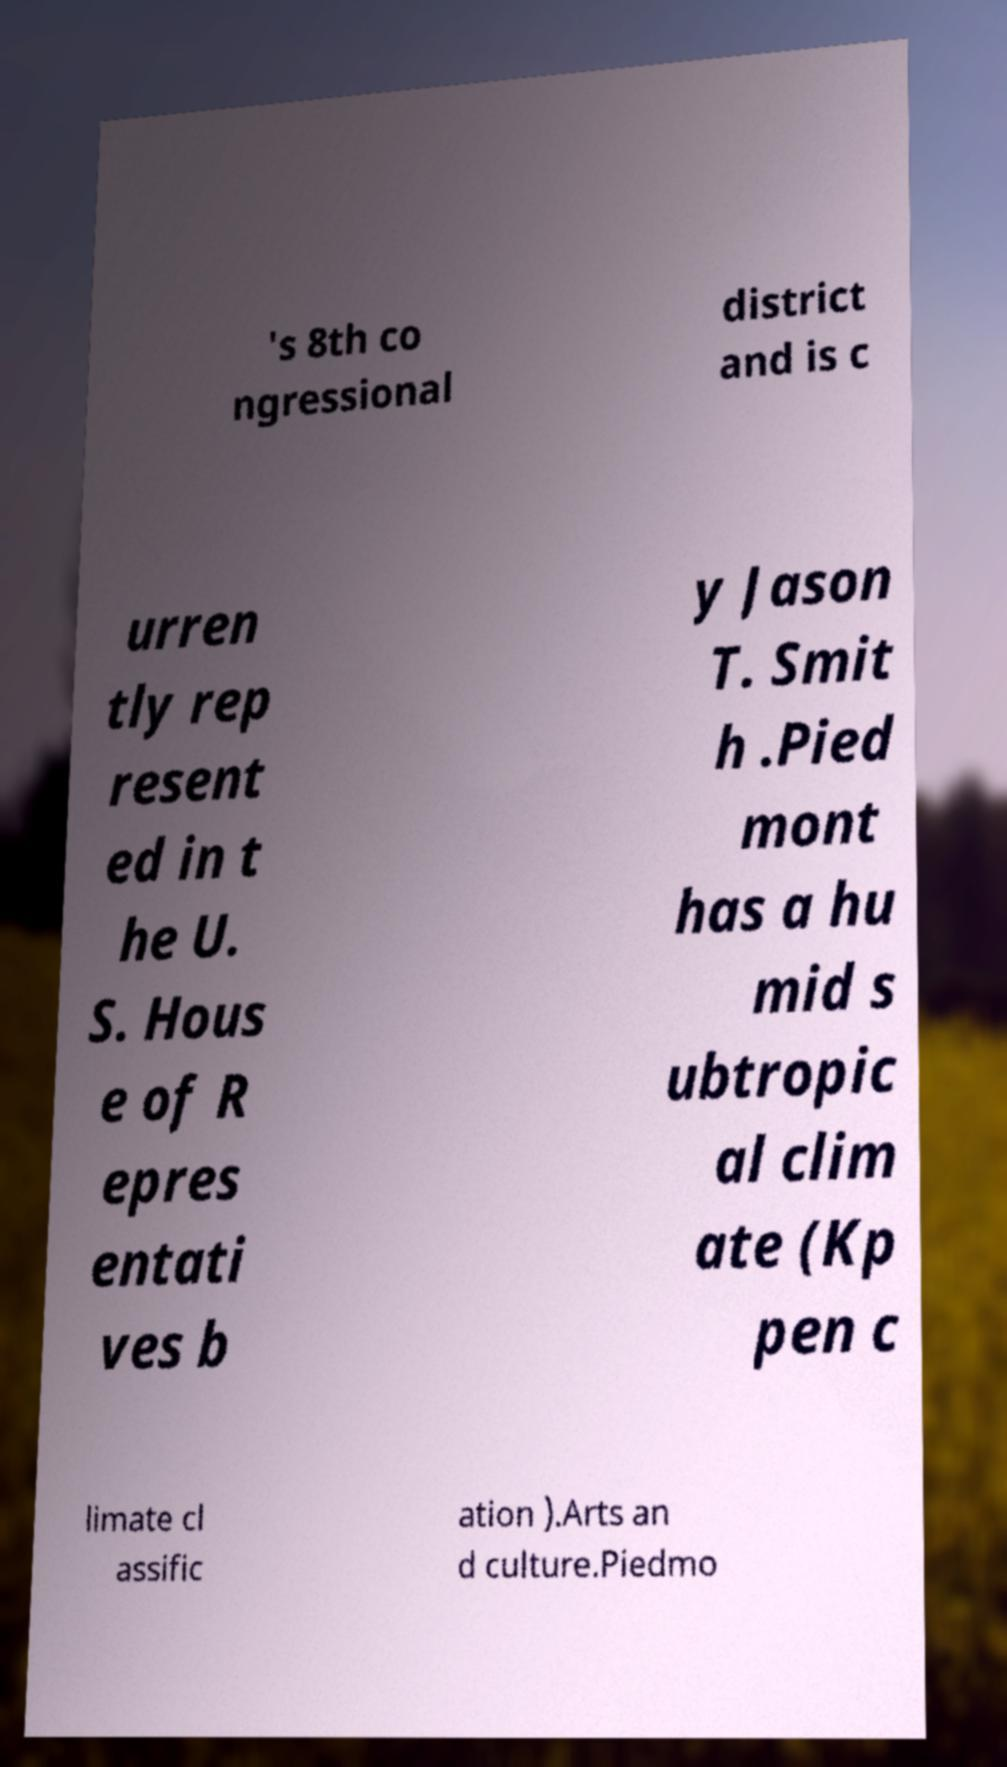There's text embedded in this image that I need extracted. Can you transcribe it verbatim? 's 8th co ngressional district and is c urren tly rep resent ed in t he U. S. Hous e of R epres entati ves b y Jason T. Smit h .Pied mont has a hu mid s ubtropic al clim ate (Kp pen c limate cl assific ation ).Arts an d culture.Piedmo 